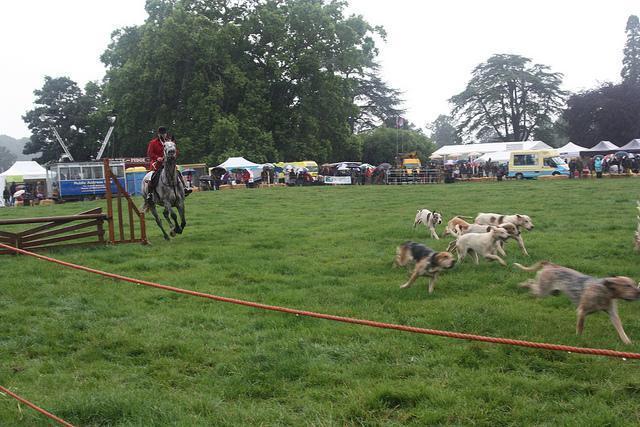How many red suitcases are in this picture?
Give a very brief answer. 0. 